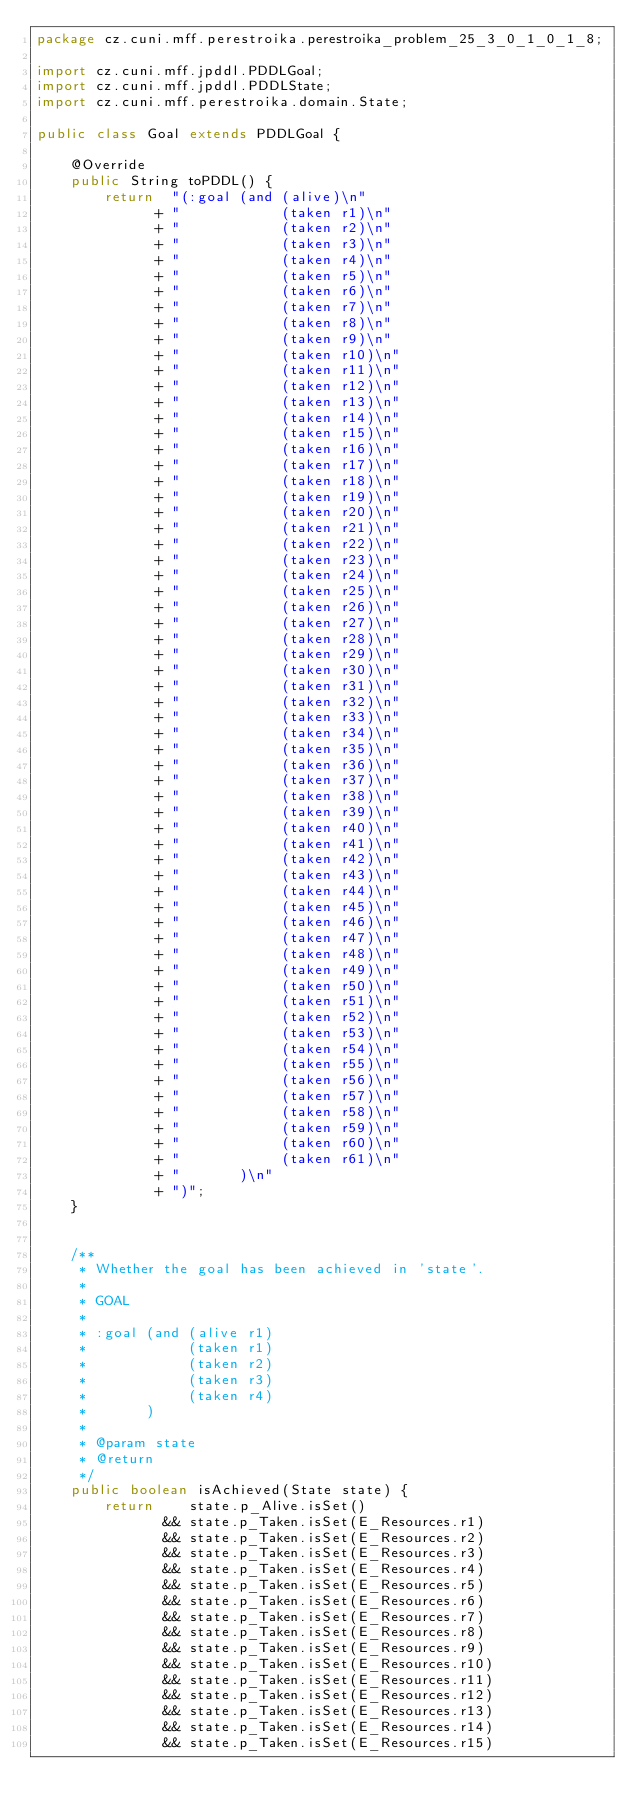Convert code to text. <code><loc_0><loc_0><loc_500><loc_500><_Java_>package cz.cuni.mff.perestroika.perestroika_problem_25_3_0_1_0_1_8;

import cz.cuni.mff.jpddl.PDDLGoal;
import cz.cuni.mff.jpddl.PDDLState;
import cz.cuni.mff.perestroika.domain.State;

public class Goal extends PDDLGoal {
	
	@Override
	public String toPDDL() {
		return  "(:goal (and (alive)\n"
			  + "            (taken r1)\n"			
			  + "            (taken r2)\n"			
			  + "            (taken r3)\n"			
			  + "            (taken r4)\n"			
			  + "            (taken r5)\n"			
			  + "            (taken r6)\n"			
			  + "            (taken r7)\n"			
			  + "            (taken r8)\n"			
			  + "            (taken r9)\n"			
			  + "            (taken r10)\n"			
			  + "            (taken r11)\n"			
			  + "            (taken r12)\n"			
			  + "            (taken r13)\n"			
			  + "            (taken r14)\n"			
			  + "            (taken r15)\n"			
			  + "            (taken r16)\n"			
			  + "            (taken r17)\n"			
			  + "            (taken r18)\n"			
			  + "            (taken r19)\n"			
			  + "            (taken r20)\n"			
			  + "            (taken r21)\n"			
			  + "            (taken r22)\n"			
			  + "            (taken r23)\n"			
			  + "            (taken r24)\n"			
			  + "            (taken r25)\n"			
			  + "            (taken r26)\n"			
			  + "            (taken r27)\n"			
			  + "            (taken r28)\n"			
			  + "            (taken r29)\n"			
			  + "            (taken r30)\n"			
			  + "            (taken r31)\n"			
			  + "            (taken r32)\n"			
			  + "            (taken r33)\n"			
			  + "            (taken r34)\n"			
			  + "            (taken r35)\n"			
			  + "            (taken r36)\n"			
			  + "            (taken r37)\n"			
			  + "            (taken r38)\n"			
			  + "            (taken r39)\n"			
			  + "            (taken r40)\n"			
			  + "            (taken r41)\n"			
			  + "            (taken r42)\n"			
			  + "            (taken r43)\n"			
			  + "            (taken r44)\n"			
			  + "            (taken r45)\n"			
			  + "            (taken r46)\n"			
			  + "            (taken r47)\n"			
			  + "            (taken r48)\n"			
			  + "            (taken r49)\n"			
			  + "            (taken r50)\n"			
			  + "            (taken r51)\n"			
			  + "            (taken r52)\n"			
			  + "            (taken r53)\n"			
			  + "            (taken r54)\n"			
			  + "            (taken r55)\n"			
			  + "            (taken r56)\n"			
			  + "            (taken r57)\n"			
			  + "            (taken r58)\n"			
			  + "            (taken r59)\n"			
			  + "            (taken r60)\n"			
			  + "            (taken r61)\n"			
			  + "       )\n"
			  + ")";
	}

	
	/**
	 * Whether the goal has been achieved in 'state'.
	 * 
	 * GOAL
	 * 
	 * :goal (and (alive r1)
     *            (taken r1)
     *            (taken r2)
     *            (taken r3)
     *            (taken r4)
     *       )
	 * 
	 * @param state
	 * @return
	 */
	public boolean isAchieved(State state) {
		return    state.p_Alive.isSet()
			   && state.p_Taken.isSet(E_Resources.r1)
			   && state.p_Taken.isSet(E_Resources.r2)
			   && state.p_Taken.isSet(E_Resources.r3)
			   && state.p_Taken.isSet(E_Resources.r4)
			   && state.p_Taken.isSet(E_Resources.r5)
			   && state.p_Taken.isSet(E_Resources.r6)
			   && state.p_Taken.isSet(E_Resources.r7)
			   && state.p_Taken.isSet(E_Resources.r8)
			   && state.p_Taken.isSet(E_Resources.r9)
			   && state.p_Taken.isSet(E_Resources.r10)
			   && state.p_Taken.isSet(E_Resources.r11)
			   && state.p_Taken.isSet(E_Resources.r12)
			   && state.p_Taken.isSet(E_Resources.r13)
			   && state.p_Taken.isSet(E_Resources.r14)
			   && state.p_Taken.isSet(E_Resources.r15)</code> 